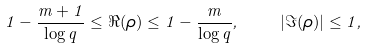<formula> <loc_0><loc_0><loc_500><loc_500>1 - \frac { m + 1 } { \log { q } } \leq \Re ( \rho ) \leq 1 - \frac { m } { \log { q } } , \quad | \Im ( \rho ) | \leq 1 ,</formula> 